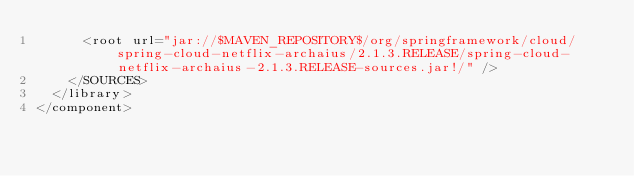<code> <loc_0><loc_0><loc_500><loc_500><_XML_>      <root url="jar://$MAVEN_REPOSITORY$/org/springframework/cloud/spring-cloud-netflix-archaius/2.1.3.RELEASE/spring-cloud-netflix-archaius-2.1.3.RELEASE-sources.jar!/" />
    </SOURCES>
  </library>
</component></code> 